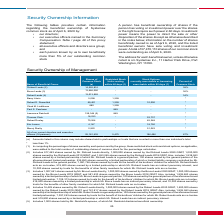From Systemax's financial document, What is the percent of common stock owned by Richard Leeds and Bruce Leeds? The document shows two values: 38% and 36%. From the document: "Richard Leeds (2) 14,526,816 - - 38% Bruce Leeds (3) 13,686,090 - - 36%..." Also, How many shares of common stock are owned by Richard Leeds and Bruce Leeds? The document shows two values: 14,526,816 and 13,686,090. From the document: "Richard Leeds (2) 14,526,816 - - 38% Bruce Leeds (3) 13,686,090 - - 36%..." Also, What is the percent of common stock owned by Barry Litwin and Robert D. Rosenthal? The document shows two values: less than 1% and less than 1%. From the document: "* less than 1%..." Also, can you calculate: What is the total shares of common stock owned by the top three shareholders of the company? Based on the calculation: 14,526,816 + 13,686,090 + 13,013,992 , the result is 41226898. This is based on the information: "Robert Leeds (4) 13,013,992 - - 34% Richard Leeds (2) 14,526,816 - - 38% Bruce Leeds (3) 13,686,090 - - 36%..." The key data points involved are: 13,013,992, 13,686,090, 14,526,816. Also, can you calculate: What percentage of the total restricted stock units vesting within 60 days are owned by Barry Litwin?  Based on the calculation: 1,259/5,475 , the result is 23 (percentage). This is based on the information: "Barry Litwin 5,098 1,259 * rs and executive officers (16 persons) 25,181,435 5,475 196,496 67%..." The key data points involved are: 1,259, 5,475. Also, can you calculate: What percentage of Lawrence Reinhold's shares of common stock is owned by his spouse? Based on the calculation: 1,000/159,344 , the result is 0.63 (percentage). This is based on the information: "Lawrence Reinhold 159,344 (5) 849 - * 7,462 shares owned by Mr. Richard Leeds directly, 1,000,000 shares owned by the Richard Leeds 2020 GRAT, 1,000,000 shares owned by the Richard Leeds 2019 G..." The key data points involved are: 1,000, 159,344. 